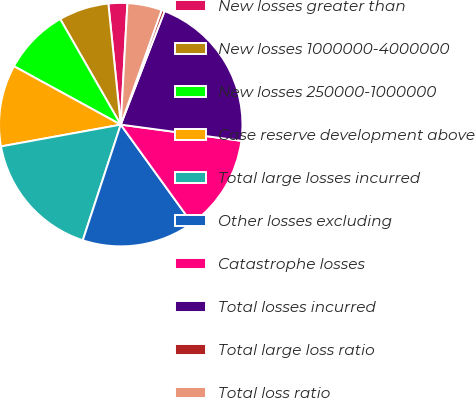Convert chart to OTSL. <chart><loc_0><loc_0><loc_500><loc_500><pie_chart><fcel>New losses greater than<fcel>New losses 1000000-4000000<fcel>New losses 250000-1000000<fcel>Case reserve development above<fcel>Total large losses incurred<fcel>Other losses excluding<fcel>Catastrophe losses<fcel>Total losses incurred<fcel>Total large loss ratio<fcel>Total loss ratio<nl><fcel>2.5%<fcel>6.66%<fcel>8.75%<fcel>10.83%<fcel>17.09%<fcel>15.0%<fcel>12.92%<fcel>21.26%<fcel>0.41%<fcel>4.58%<nl></chart> 